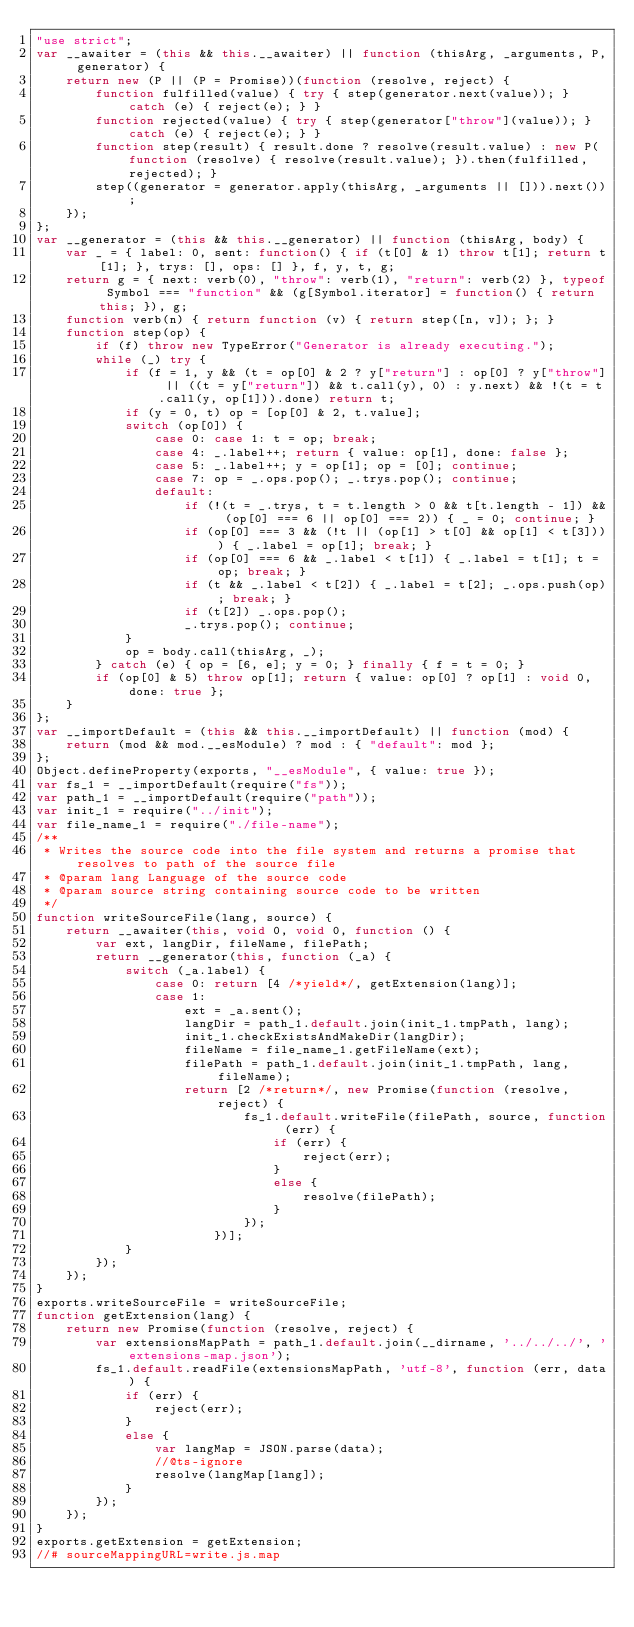Convert code to text. <code><loc_0><loc_0><loc_500><loc_500><_JavaScript_>"use strict";
var __awaiter = (this && this.__awaiter) || function (thisArg, _arguments, P, generator) {
    return new (P || (P = Promise))(function (resolve, reject) {
        function fulfilled(value) { try { step(generator.next(value)); } catch (e) { reject(e); } }
        function rejected(value) { try { step(generator["throw"](value)); } catch (e) { reject(e); } }
        function step(result) { result.done ? resolve(result.value) : new P(function (resolve) { resolve(result.value); }).then(fulfilled, rejected); }
        step((generator = generator.apply(thisArg, _arguments || [])).next());
    });
};
var __generator = (this && this.__generator) || function (thisArg, body) {
    var _ = { label: 0, sent: function() { if (t[0] & 1) throw t[1]; return t[1]; }, trys: [], ops: [] }, f, y, t, g;
    return g = { next: verb(0), "throw": verb(1), "return": verb(2) }, typeof Symbol === "function" && (g[Symbol.iterator] = function() { return this; }), g;
    function verb(n) { return function (v) { return step([n, v]); }; }
    function step(op) {
        if (f) throw new TypeError("Generator is already executing.");
        while (_) try {
            if (f = 1, y && (t = op[0] & 2 ? y["return"] : op[0] ? y["throw"] || ((t = y["return"]) && t.call(y), 0) : y.next) && !(t = t.call(y, op[1])).done) return t;
            if (y = 0, t) op = [op[0] & 2, t.value];
            switch (op[0]) {
                case 0: case 1: t = op; break;
                case 4: _.label++; return { value: op[1], done: false };
                case 5: _.label++; y = op[1]; op = [0]; continue;
                case 7: op = _.ops.pop(); _.trys.pop(); continue;
                default:
                    if (!(t = _.trys, t = t.length > 0 && t[t.length - 1]) && (op[0] === 6 || op[0] === 2)) { _ = 0; continue; }
                    if (op[0] === 3 && (!t || (op[1] > t[0] && op[1] < t[3]))) { _.label = op[1]; break; }
                    if (op[0] === 6 && _.label < t[1]) { _.label = t[1]; t = op; break; }
                    if (t && _.label < t[2]) { _.label = t[2]; _.ops.push(op); break; }
                    if (t[2]) _.ops.pop();
                    _.trys.pop(); continue;
            }
            op = body.call(thisArg, _);
        } catch (e) { op = [6, e]; y = 0; } finally { f = t = 0; }
        if (op[0] & 5) throw op[1]; return { value: op[0] ? op[1] : void 0, done: true };
    }
};
var __importDefault = (this && this.__importDefault) || function (mod) {
    return (mod && mod.__esModule) ? mod : { "default": mod };
};
Object.defineProperty(exports, "__esModule", { value: true });
var fs_1 = __importDefault(require("fs"));
var path_1 = __importDefault(require("path"));
var init_1 = require("../init");
var file_name_1 = require("./file-name");
/**
 * Writes the source code into the file system and returns a promise that resolves to path of the source file
 * @param lang Language of the source code
 * @param source string containing source code to be written
 */
function writeSourceFile(lang, source) {
    return __awaiter(this, void 0, void 0, function () {
        var ext, langDir, fileName, filePath;
        return __generator(this, function (_a) {
            switch (_a.label) {
                case 0: return [4 /*yield*/, getExtension(lang)];
                case 1:
                    ext = _a.sent();
                    langDir = path_1.default.join(init_1.tmpPath, lang);
                    init_1.checkExistsAndMakeDir(langDir);
                    fileName = file_name_1.getFileName(ext);
                    filePath = path_1.default.join(init_1.tmpPath, lang, fileName);
                    return [2 /*return*/, new Promise(function (resolve, reject) {
                            fs_1.default.writeFile(filePath, source, function (err) {
                                if (err) {
                                    reject(err);
                                }
                                else {
                                    resolve(filePath);
                                }
                            });
                        })];
            }
        });
    });
}
exports.writeSourceFile = writeSourceFile;
function getExtension(lang) {
    return new Promise(function (resolve, reject) {
        var extensionsMapPath = path_1.default.join(__dirname, '../../../', 'extensions-map.json');
        fs_1.default.readFile(extensionsMapPath, 'utf-8', function (err, data) {
            if (err) {
                reject(err);
            }
            else {
                var langMap = JSON.parse(data);
                //@ts-ignore
                resolve(langMap[lang]);
            }
        });
    });
}
exports.getExtension = getExtension;
//# sourceMappingURL=write.js.map</code> 